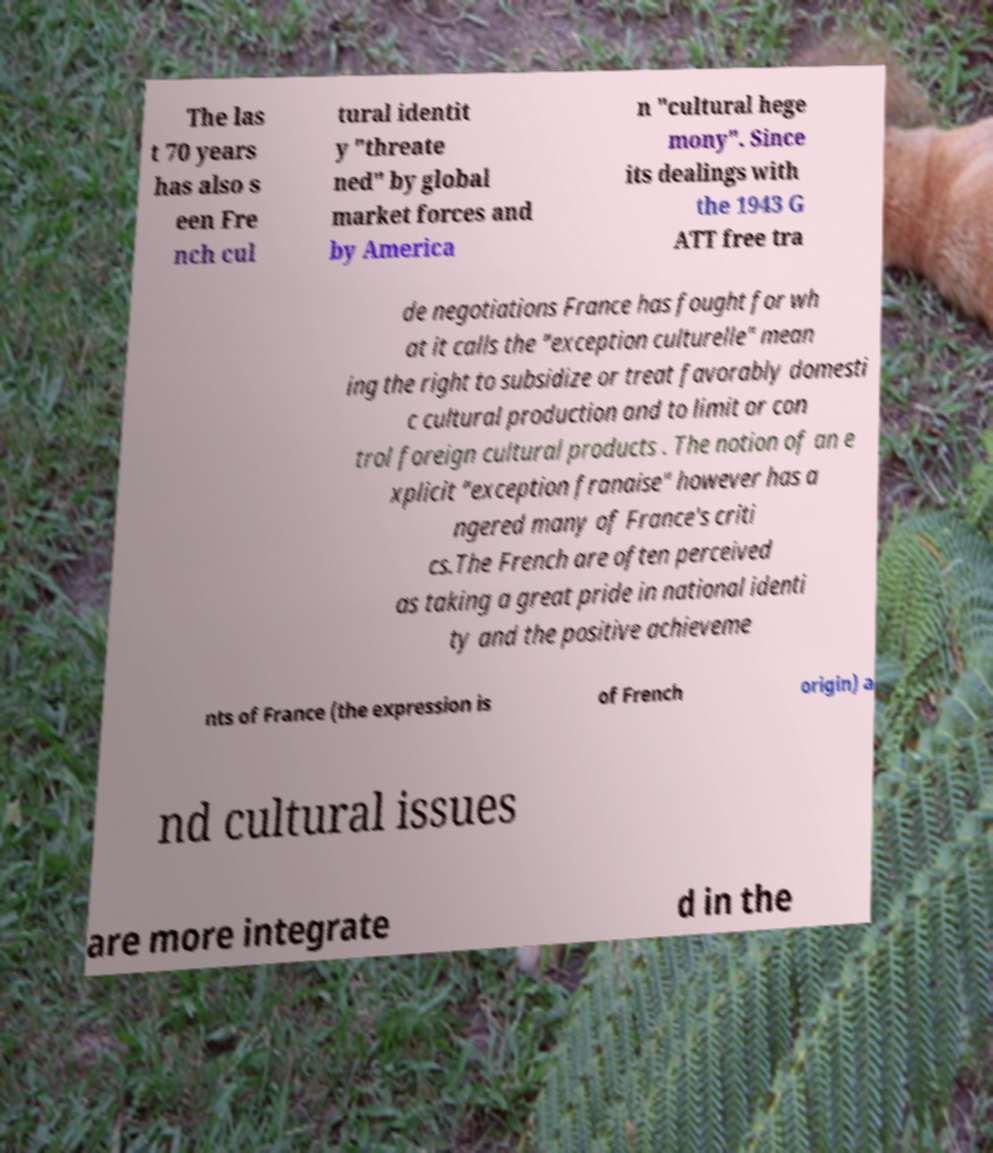Can you accurately transcribe the text from the provided image for me? The las t 70 years has also s een Fre nch cul tural identit y "threate ned" by global market forces and by America n "cultural hege mony". Since its dealings with the 1943 G ATT free tra de negotiations France has fought for wh at it calls the "exception culturelle" mean ing the right to subsidize or treat favorably domesti c cultural production and to limit or con trol foreign cultural products . The notion of an e xplicit "exception franaise" however has a ngered many of France's criti cs.The French are often perceived as taking a great pride in national identi ty and the positive achieveme nts of France (the expression is of French origin) a nd cultural issues are more integrate d in the 